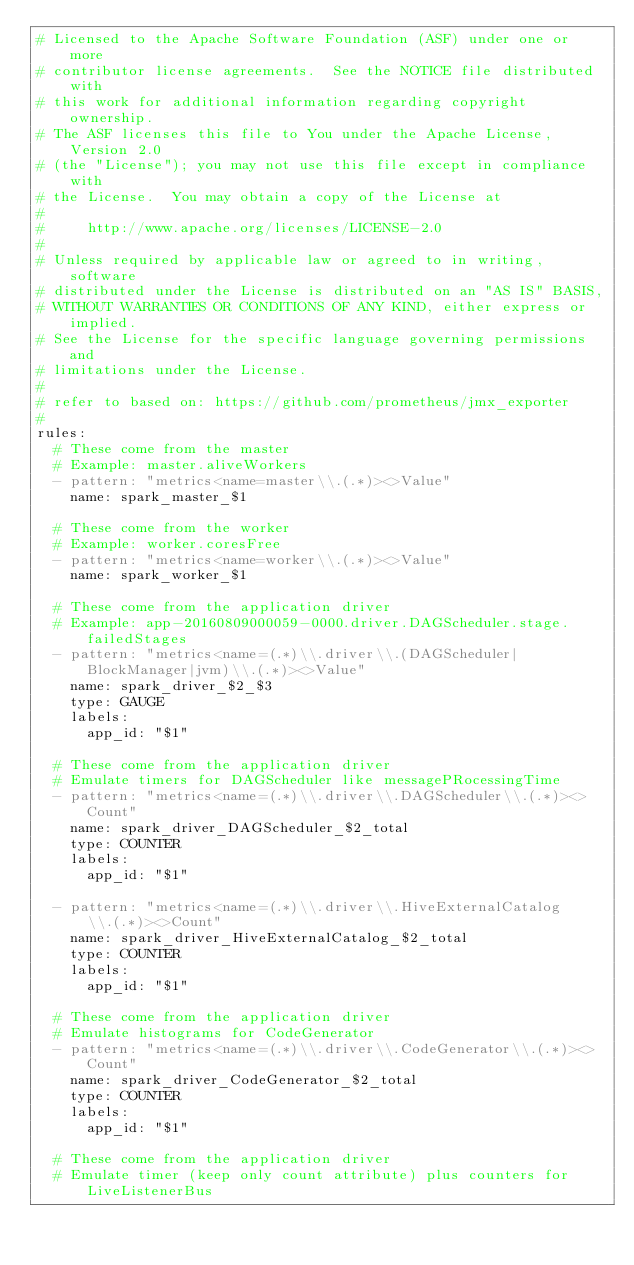<code> <loc_0><loc_0><loc_500><loc_500><_YAML_># Licensed to the Apache Software Foundation (ASF) under one or more
# contributor license agreements.  See the NOTICE file distributed with
# this work for additional information regarding copyright ownership.
# The ASF licenses this file to You under the Apache License, Version 2.0
# (the "License"); you may not use this file except in compliance with
# the License.  You may obtain a copy of the License at
#
#     http://www.apache.org/licenses/LICENSE-2.0
#
# Unless required by applicable law or agreed to in writing, software
# distributed under the License is distributed on an "AS IS" BASIS,
# WITHOUT WARRANTIES OR CONDITIONS OF ANY KIND, either express or implied.
# See the License for the specific language governing permissions and
# limitations under the License.
#
# refer to based on: https://github.com/prometheus/jmx_exporter
#
rules:
  # These come from the master
  # Example: master.aliveWorkers
  - pattern: "metrics<name=master\\.(.*)><>Value"
    name: spark_master_$1

  # These come from the worker
  # Example: worker.coresFree
  - pattern: "metrics<name=worker\\.(.*)><>Value"
    name: spark_worker_$1

  # These come from the application driver
  # Example: app-20160809000059-0000.driver.DAGScheduler.stage.failedStages
  - pattern: "metrics<name=(.*)\\.driver\\.(DAGScheduler|BlockManager|jvm)\\.(.*)><>Value"
    name: spark_driver_$2_$3
    type: GAUGE
    labels:
      app_id: "$1"

  # These come from the application driver
  # Emulate timers for DAGScheduler like messagePRocessingTime
  - pattern: "metrics<name=(.*)\\.driver\\.DAGScheduler\\.(.*)><>Count"
    name: spark_driver_DAGScheduler_$2_total
    type: COUNTER
    labels:
      app_id: "$1"

  - pattern: "metrics<name=(.*)\\.driver\\.HiveExternalCatalog\\.(.*)><>Count"
    name: spark_driver_HiveExternalCatalog_$2_total
    type: COUNTER
    labels:
      app_id: "$1"

  # These come from the application driver
  # Emulate histograms for CodeGenerator
  - pattern: "metrics<name=(.*)\\.driver\\.CodeGenerator\\.(.*)><>Count"
    name: spark_driver_CodeGenerator_$2_total
    type: COUNTER
    labels:
      app_id: "$1"

  # These come from the application driver
  # Emulate timer (keep only count attribute) plus counters for LiveListenerBus</code> 